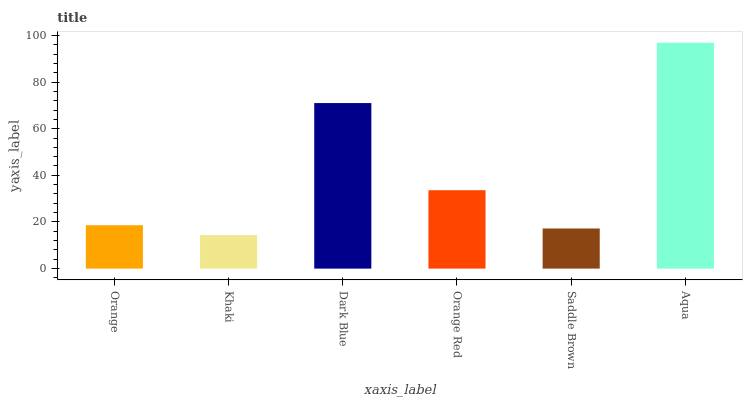Is Khaki the minimum?
Answer yes or no. Yes. Is Aqua the maximum?
Answer yes or no. Yes. Is Dark Blue the minimum?
Answer yes or no. No. Is Dark Blue the maximum?
Answer yes or no. No. Is Dark Blue greater than Khaki?
Answer yes or no. Yes. Is Khaki less than Dark Blue?
Answer yes or no. Yes. Is Khaki greater than Dark Blue?
Answer yes or no. No. Is Dark Blue less than Khaki?
Answer yes or no. No. Is Orange Red the high median?
Answer yes or no. Yes. Is Orange the low median?
Answer yes or no. Yes. Is Saddle Brown the high median?
Answer yes or no. No. Is Khaki the low median?
Answer yes or no. No. 